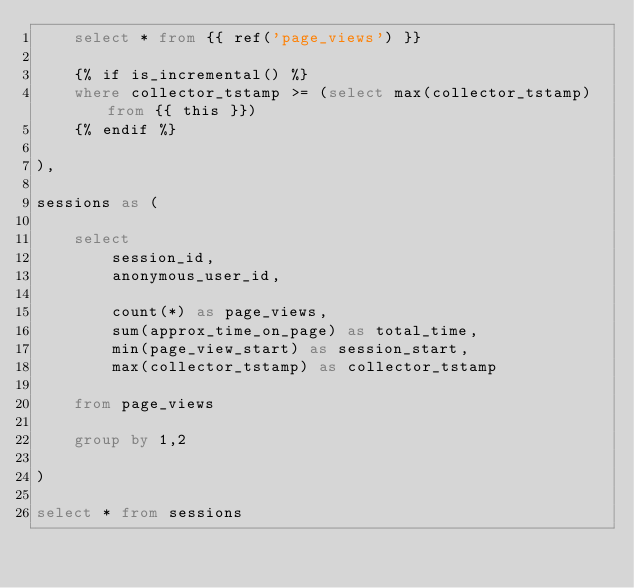Convert code to text. <code><loc_0><loc_0><loc_500><loc_500><_SQL_>    select * from {{ ref('page_views') }}

    {% if is_incremental() %}
    where collector_tstamp >= (select max(collector_tstamp) from {{ this }})
    {% endif %}

),

sessions as (

    select
        session_id,
        anonymous_user_id,

        count(*) as page_views,
        sum(approx_time_on_page) as total_time,
        min(page_view_start) as session_start,
        max(collector_tstamp) as collector_tstamp

    from page_views

    group by 1,2

)

select * from sessions
</code> 